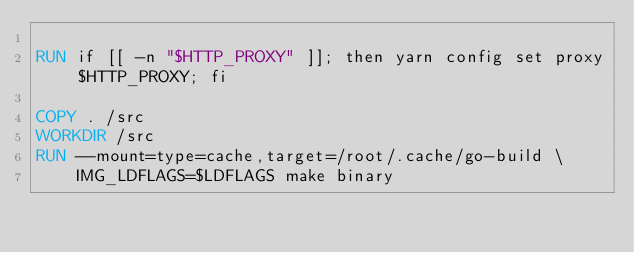Convert code to text. <code><loc_0><loc_0><loc_500><loc_500><_Dockerfile_>
RUN if [[ -n "$HTTP_PROXY" ]]; then yarn config set proxy $HTTP_PROXY; fi

COPY . /src
WORKDIR /src
RUN --mount=type=cache,target=/root/.cache/go-build \
    IMG_LDFLAGS=$LDFLAGS make binary
</code> 